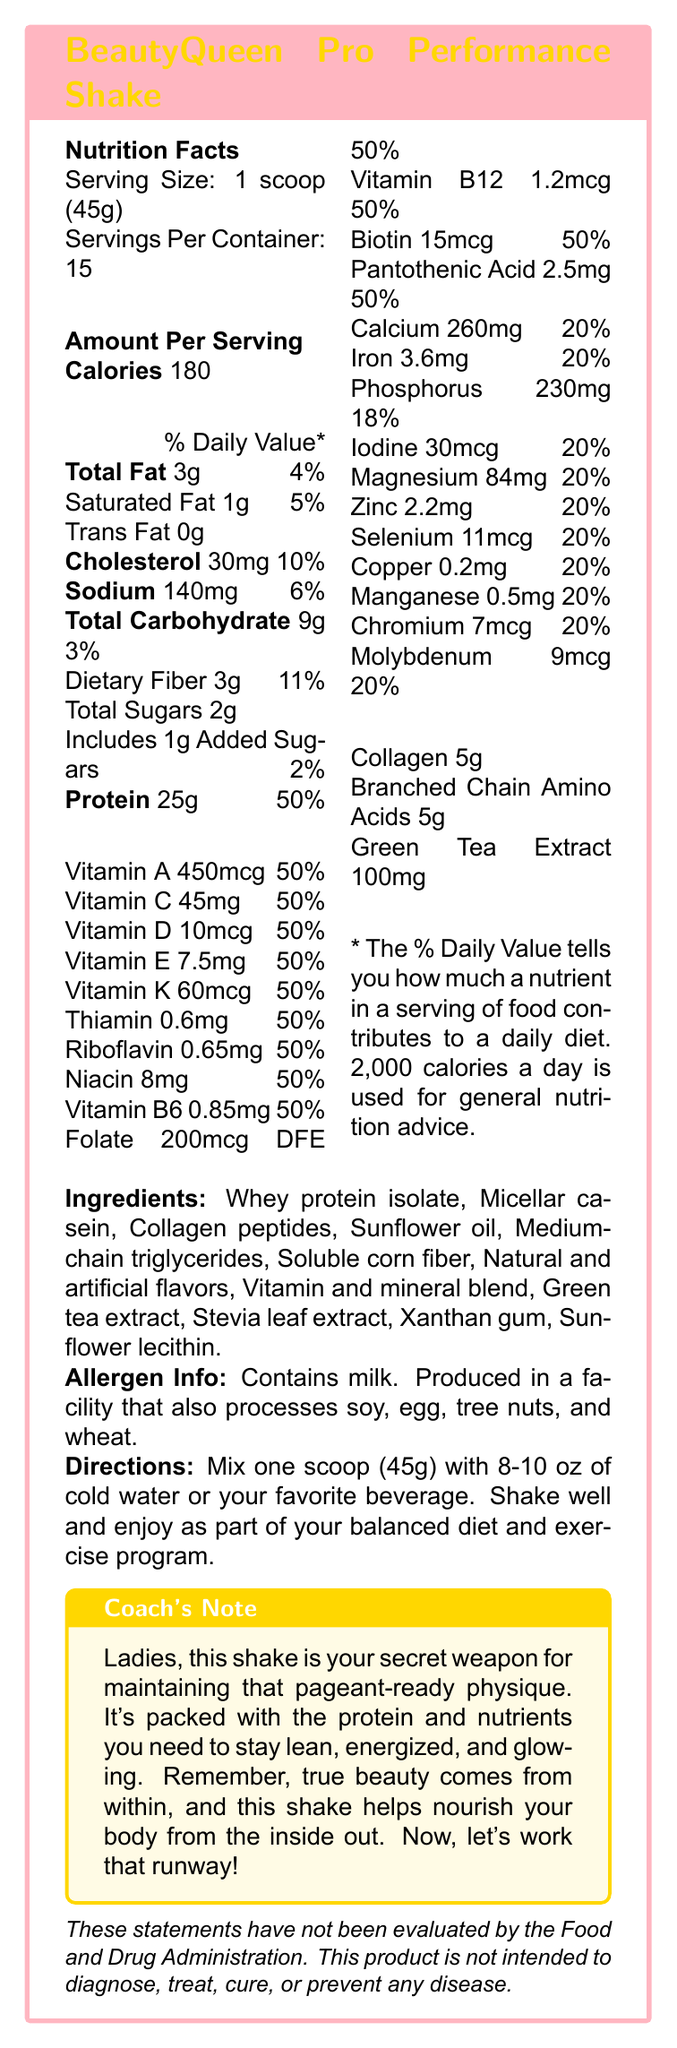what is the serving size for the BeautyQueen Pro Performance Shake? The document specifies that the serving size is 1 scoop, which weighs 45 grams.
Answer: 1 scoop (45g) how many calories are in one serving? The document states that one serving contains 180 calories.
Answer: 180 how much protein is in each serving, and what percentage of the daily value does it represent? The document lists that each serving contains 25 grams of protein and this represents 50% of the daily value.
Answer: 25g, 50% what are the main ingredients in the BeautyQueen Pro Performance Shake? The document provides a detailed list of ingredients.
Answer: Whey protein isolate, Micellar casein, Collagen peptides, Sunflower oil, Medium-chain triglycerides, Soluble corn fiber, Natural and artificial flavors, Vitamin and mineral blend, Green tea extract, Stevia leaf extract, Xanthan gum, Sunflower lecithin which mineral present in the shake has the highest daily value percentage? The mineral with the highest daily value percentage is calcium at 20%.
Answer: Calcium what is the total carbohydrate content per serving, and how much of it is dietary fiber? The document states that the total carbohydrate content per serving is 9 grams, out of which 3 grams are dietary fiber.
Answer: 9g total, 3g dietary fiber which of the following vitamins are included in the BeautyQueen Pro Performance Shake? A. Vitamin D B. Vitamin B6 C. Vitamin E D. All of the above The document lists Vitamin D, Vitamin B6, and Vitamin E as part of the vitamin content in the shake.
Answer: D. All of the above how many servings are in one container of the BeautyQueen Pro Performance Shake? A. 10 B. 12 C. 15 D. 20 The document states that there are 15 servings per container.
Answer: C. 15 does the shake contain any cholesterol? The document remarks that each serving contains 30 mg of cholesterol.
Answer: Yes are there any allergens in the BeautyQueen Pro Performance Shake? The document states that the shake contains milk and is produced in a facility that also processes soy, egg, tree nuts, and wheat.
Answer: Yes summarize the main idea of this document. The document aims to inform users about the nutritional content, ingredients, and benefits of the BeautyQueen Pro Performance Shake, emphasizing its suitability for maintaining a lean, energized, and glowing physique crucial for beauty pageant contestants.
Answer: The document provides detailed nutritional information for the BeautyQueen Pro Performance Shake, a high-protein meal replacement shake designed for beauty pageant contestants. It lists serving size, calorie content, and percentages of daily values for various nutrients along with ingredients and allergen information. There is also a coach's note highlighting the benefits of the shake. can we determine the exact cost per serving from this document? The document does not provide any pricing information, so the cost per serving cannot be calculated from the visual details provided.
Answer: Cannot be determined 